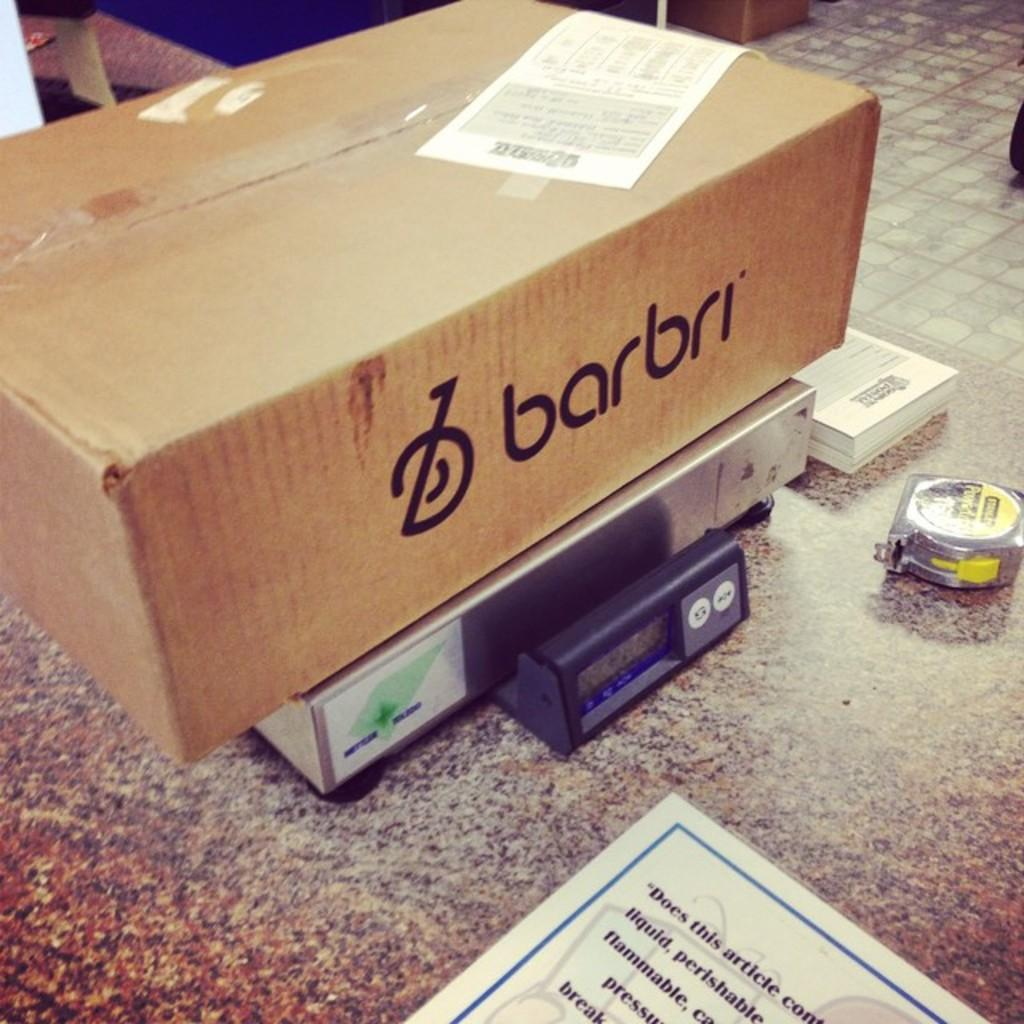<image>
Describe the image concisely. A box labeled barbri on top a a scale next to a measuring tape. 